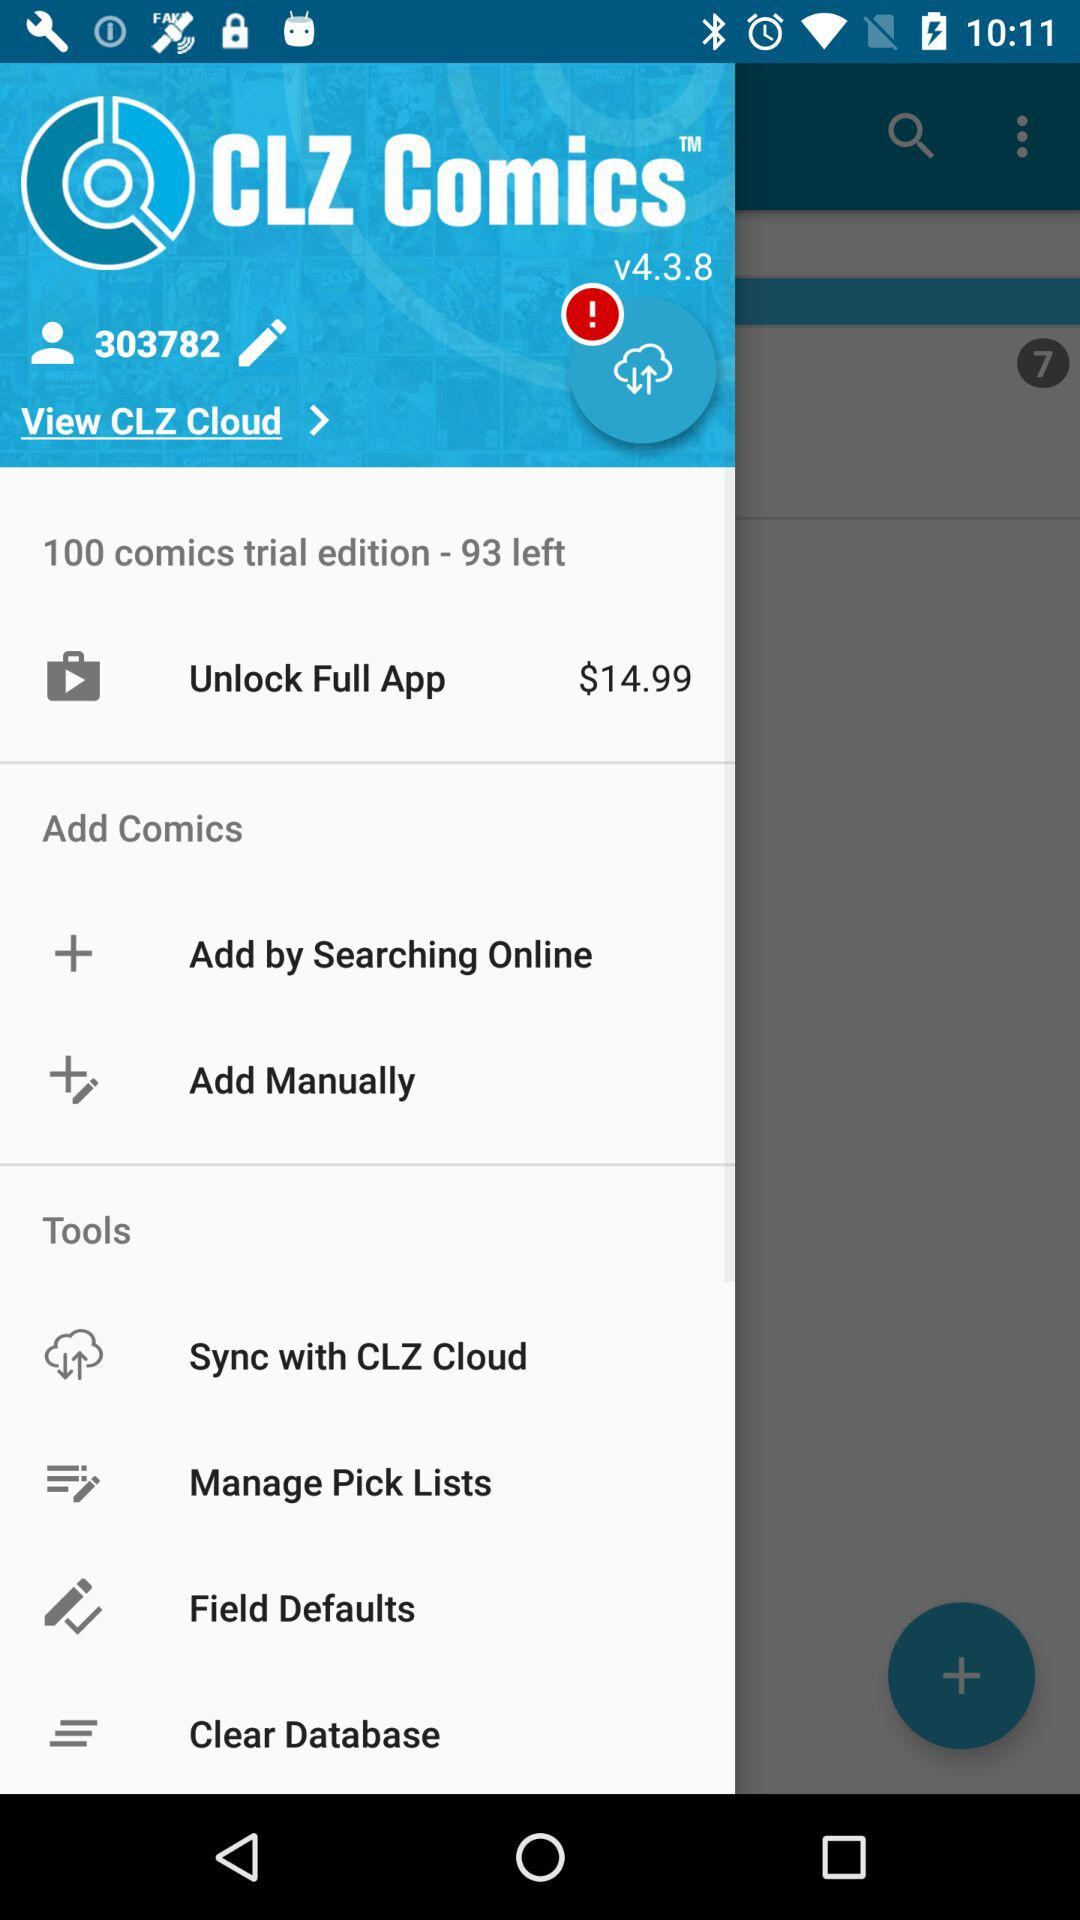What is the price to unlock the full app? The price to unlock the full app is $14.99. 